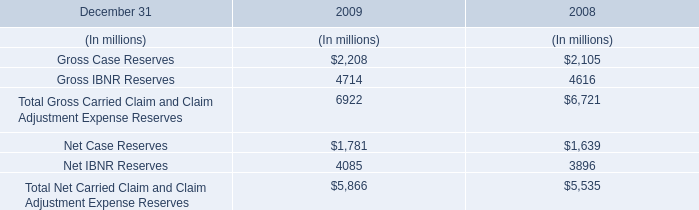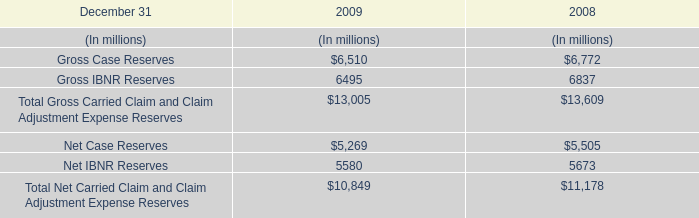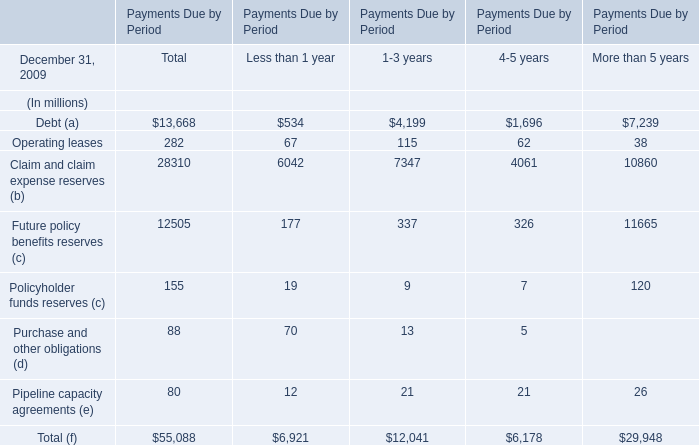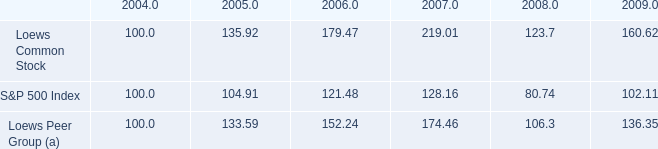what is the return on investment for s&p500 from 2004 to 2006? 
Computations: ((121.48 - 100) / 100)
Answer: 0.2148. 